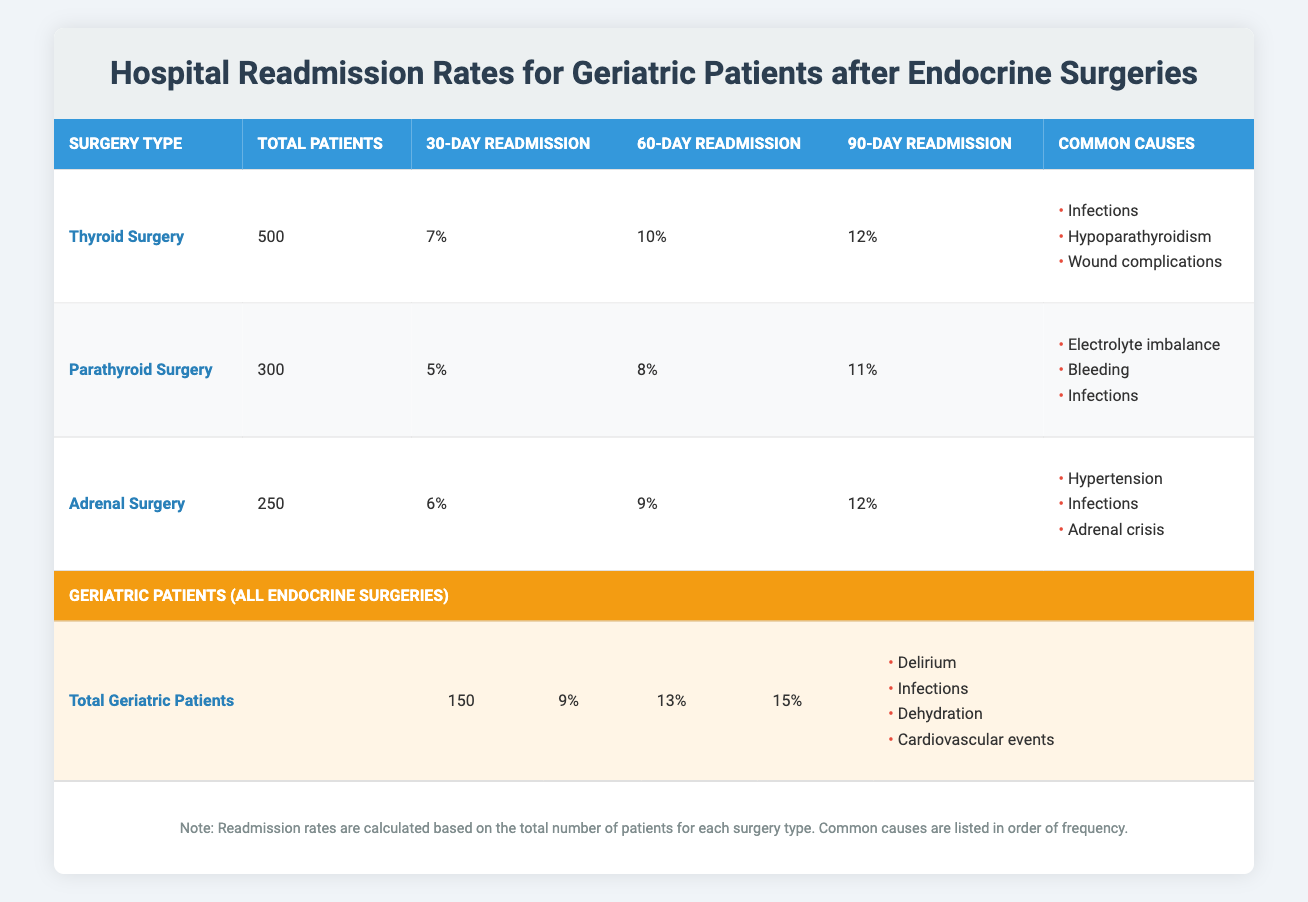What is the readmission rate within 30 days for thyroid surgery? From the table, under the "Thyroid Surgery" row, the readmission rate within 30 days is 7%.
Answer: 7% How many total patients underwent parathyroid surgery? According to the "Parathyroid Surgery" row in the table, the total number of patients is 300.
Answer: 300 What is the difference in the readmission rate within 60 days between geriatric patients and those undergoing adrenal surgery? For geriatric patients, the readmission rate within 60 days is 13%, and for adrenal surgery, it is 9%. The difference is calculated as 13% - 9% = 4%.
Answer: 4% What percentage of geriatric patients were readmitted within 90 days? The table shows that the readmission rate for geriatric patients within 90 days is 15%.
Answer: 15% True or false: The most common cause of readmission after thyroid surgery is dehydration. The table does not list dehydration as a common cause for thyroid surgery; the common causes are infections, hypoparathyroidism, and wound complications. Thus, the statement is false.
Answer: False What is the average readmission rate within 30 days for all types of surgeries listed? The readmission rates within 30 days are 7% (thyroid), 5% (parathyroid), and 6% (adrenal). The average is calculated as (7 + 5 + 6) / 3 = 6%.
Answer: 6% What are the common complications for geriatric patients after endocrine surgeries? The table lists the common complications for geriatric patients as delirium, infections, dehydration, and cardiovascular events.
Answer: Delirium, infections, dehydration, cardiovascular events How many more geriatric patients were readmitted within 60 days compared to parathyroid surgery patients? Geriatric patients have a readmission rate of 13% within 60 days, while parathyroid surgery patients have a rate of 8%. The difference is 13% - 8% = 5%.
Answer: 5% Which type of endocrine surgery has the highest readmission rate within 90 days? By comparing the readmission rates within 90 days: thyroid (12%), parathyroid (11%), and adrenal (12%), thyroid and adrenal surgeries tie for the highest rate at 12%.
Answer: Thyroid and adrenal surgeries What are the common causes of readmission for adrenal surgery? In the table, the common causes for readmission after adrenal surgery are hypertension, infections, and adrenal crisis.
Answer: Hypertension, infections, adrenal crisis 